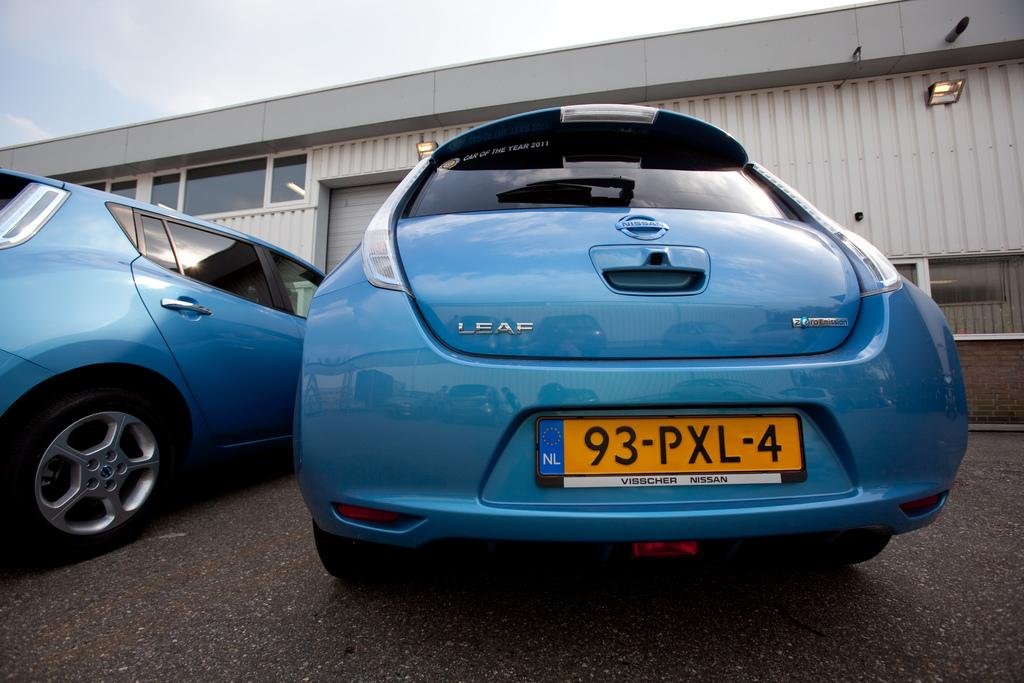What can be seen on the road in the image? There are cars parked on the road in the image. What is the status of the cars in the image? The cars are parked. What is located in front of the parked cars? There is a building in front of the cars. What is visible in the background of the image? The sky is visible in the image. What is the weather condition suggested by the sky? The sky appears to be cloudy, suggesting a potentially overcast or rainy day. What type of haircut is the building receiving in the image? There is no haircut being performed in the image; it features parked cars and a building. Can you tell me which pen the airport is using in the image? There is no airport or pen present in the image. 